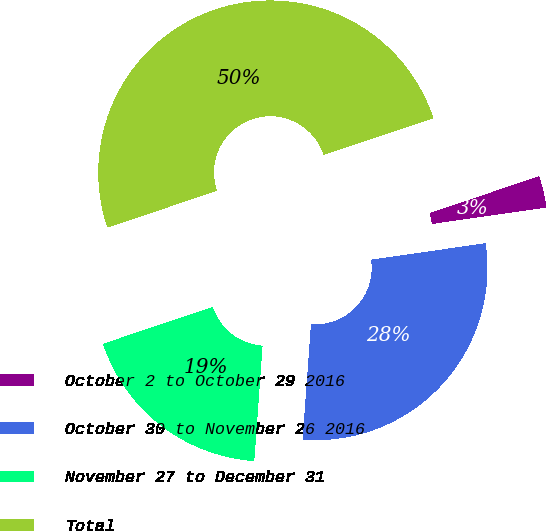Convert chart. <chart><loc_0><loc_0><loc_500><loc_500><pie_chart><fcel>October 2 to October 29 2016<fcel>October 30 to November 26 2016<fcel>November 27 to December 31<fcel>Total<nl><fcel>2.88%<fcel>28.42%<fcel>18.7%<fcel>50.0%<nl></chart> 